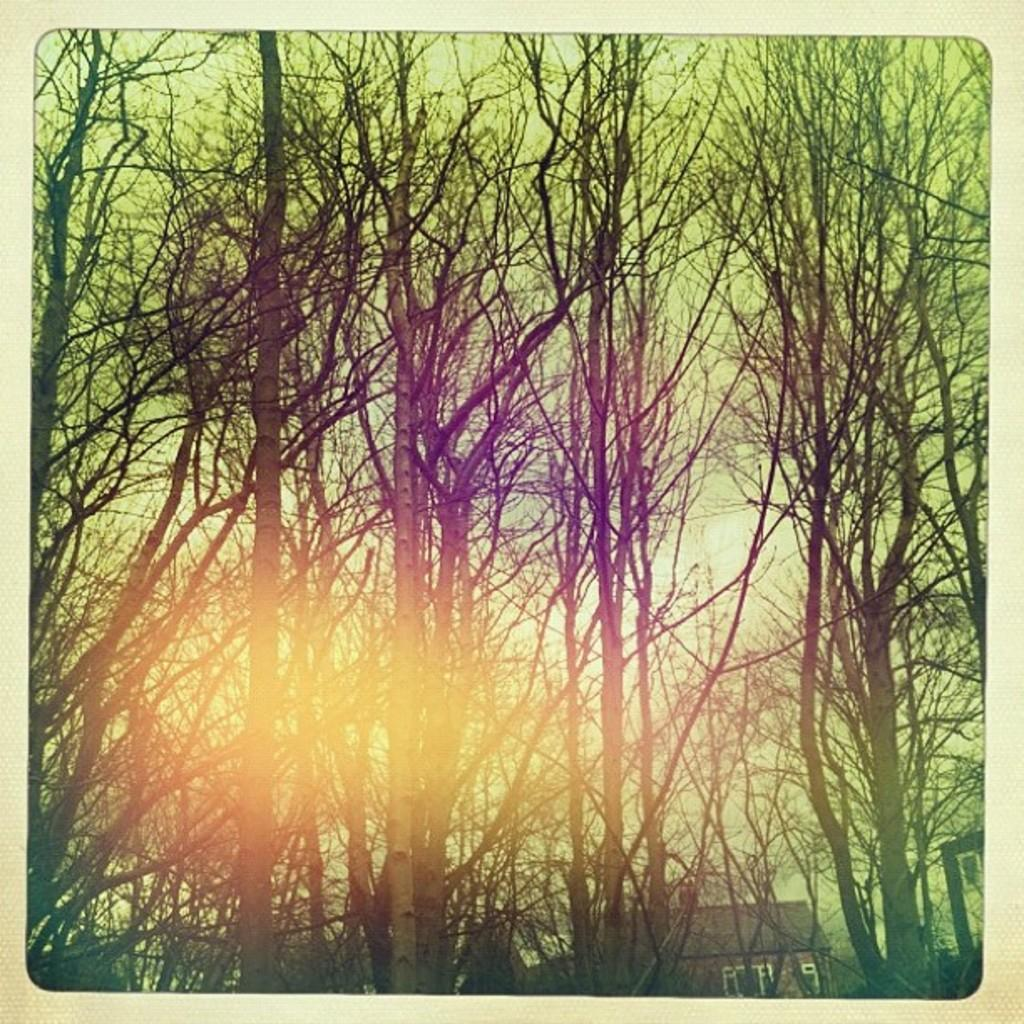What type of structure is visible in the picture? There is a building in the picture. What other elements can be seen in the picture besides the building? There are trees in the picture. How would you describe the weather based on the sky in the picture? The sky is clear in the picture, suggesting good weather. Can you tell me how many women are involved in the fight depicted in the image? There is no fight or woman present in the image; it features a building and trees with a clear sky. 